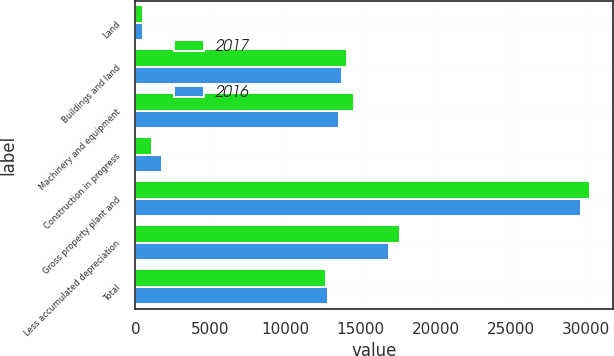Convert chart to OTSL. <chart><loc_0><loc_0><loc_500><loc_500><stacked_bar_chart><ecel><fcel>Land<fcel>Buildings and land<fcel>Machinery and equipment<fcel>Construction in progress<fcel>Gross property plant and<fcel>Less accumulated depreciation<fcel>Total<nl><fcel>2017<fcel>530<fcel>14125<fcel>14577<fcel>1081<fcel>30313<fcel>17641<fcel>12672<nl><fcel>2016<fcel>535<fcel>13796<fcel>13569<fcel>1790<fcel>29690<fcel>16883<fcel>12807<nl></chart> 